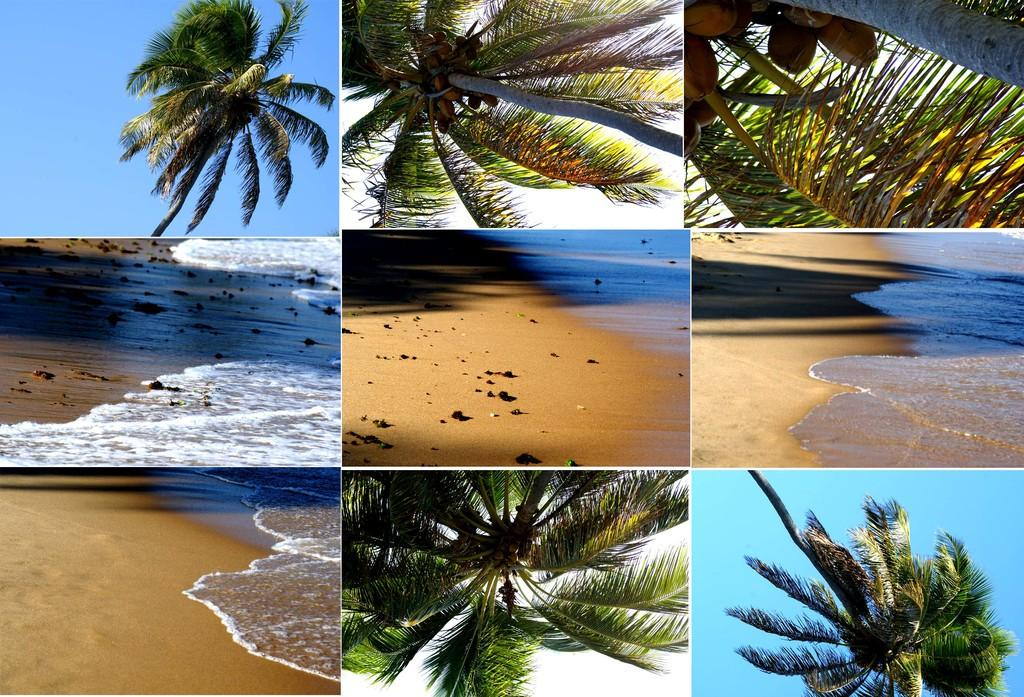What type of picture is in the image? The image contains a collage picture. What natural elements can be seen in the collage? Water, sand, trees, and the sky are visible in the collage. What type of fruit is present in the collage? Coconuts are present in the collage. How many cents does the father in the image have in his pocket? There is no father or mention of money in the image; it contains a collage with natural elements and coconuts. 